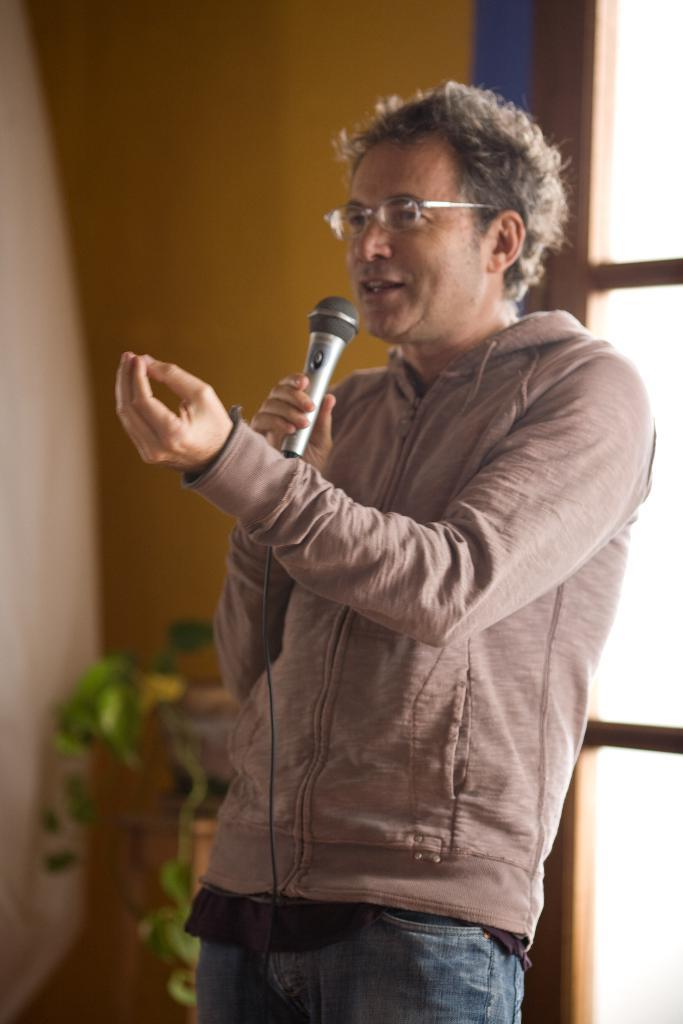What is the man in the image doing? The man is standing in the image and speaking. What is the man holding in the image? The man is holding a microphone. What type of clothing is the man wearing on his upper body? The man is wearing a jerkin. What type of clothing is the man wearing on his lower body? The man is wearing trousers. What accessory is the man wearing on his face? The man is wearing spectacles. What can be seen in the background of the image? There is a plant visible in the background of the image, and it appears to be a window. How much money is the man holding in the image? The man is not holding any money in the image; he is holding a microphone. Is the man carrying a skateboard in the image? There is no skateboard present in the image. 